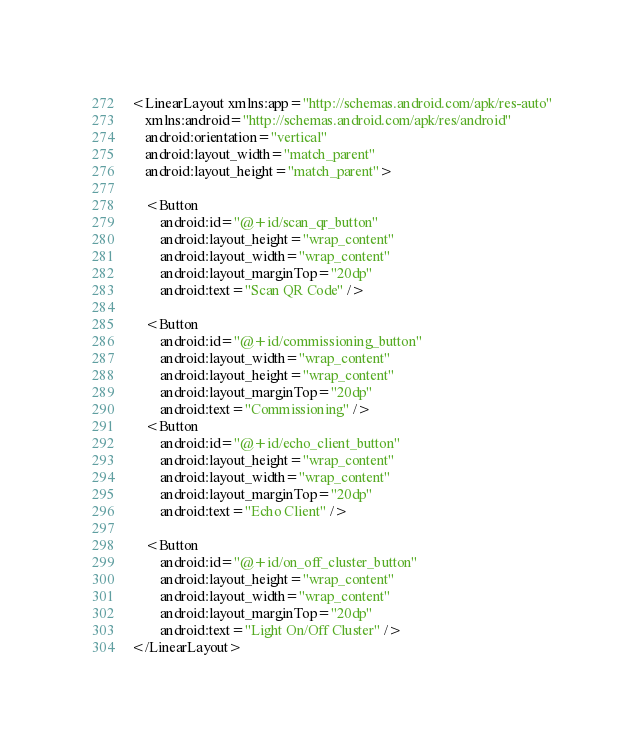Convert code to text. <code><loc_0><loc_0><loc_500><loc_500><_XML_><LinearLayout xmlns:app="http://schemas.android.com/apk/res-auto"
    xmlns:android="http://schemas.android.com/apk/res/android"
    android:orientation="vertical"
    android:layout_width="match_parent"
    android:layout_height="match_parent">

    <Button
        android:id="@+id/scan_qr_button"
        android:layout_height="wrap_content"
        android:layout_width="wrap_content"
        android:layout_marginTop="20dp"
        android:text="Scan QR Code" />

    <Button
        android:id="@+id/commissioning_button"
        android:layout_width="wrap_content"
        android:layout_height="wrap_content"
        android:layout_marginTop="20dp"
        android:text="Commissioning" />
    <Button
        android:id="@+id/echo_client_button"
        android:layout_height="wrap_content"
        android:layout_width="wrap_content"
        android:layout_marginTop="20dp"
        android:text="Echo Client" />

    <Button
        android:id="@+id/on_off_cluster_button"
        android:layout_height="wrap_content"
        android:layout_width="wrap_content"
        android:layout_marginTop="20dp"
        android:text="Light On/Off Cluster" />
</LinearLayout></code> 